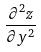<formula> <loc_0><loc_0><loc_500><loc_500>\frac { \partial ^ { 2 } z } { \partial y ^ { 2 } }</formula> 